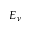<formula> <loc_0><loc_0><loc_500><loc_500>E _ { \nu }</formula> 